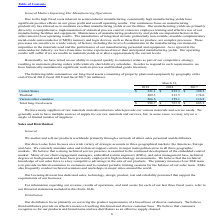From Microchip Technology's financial document, Which years does the table provide data for the company's long-lived assets? The document contains multiple relevant values: 2019, 2018, 2017. From the document: "2019 2018 2017 2019 2018 2017 2019 2018 2017..." Also, What was the amount of assets in United States in 2019? According to the financial document, 521.1 (in millions). The relevant text states: "United States $ 521.1 $ 393.3 $ 388.5..." Also, What was the amount of total long-lived assets in 2017? According to the financial document, 683.3 (in millions). The relevant text states: "Total long-lived assets $ 996.7 $ 767.9 $ 683.3..." Additionally, Which years did assets from Thailand exceed $200 million? The document shows two values: 2019 and 2018. From the document: "2019 2018 2017 2019 2018 2017..." Also, can you calculate: What was the change in assets from various other countries between 2017 and 2018? Based on the calculation: 159.1-116.8, the result is 42.3 (in millions). This is based on the information: "Various other countries 266.3 159.1 116.8 Various other countries 266.3 159.1 116.8..." The key data points involved are: 116.8, 159.1. Also, can you calculate: What was the percentage change in the total long-lived assets between 2018 and 2019? To answer this question, I need to perform calculations using the financial data. The calculation is: (996.7-767.9)/767.9, which equals 29.8 (percentage). This is based on the information: "Total long-lived assets $ 996.7 $ 767.9 $ 683.3 Total long-lived assets $ 996.7 $ 767.9 $ 683.3..." The key data points involved are: 767.9, 996.7. 